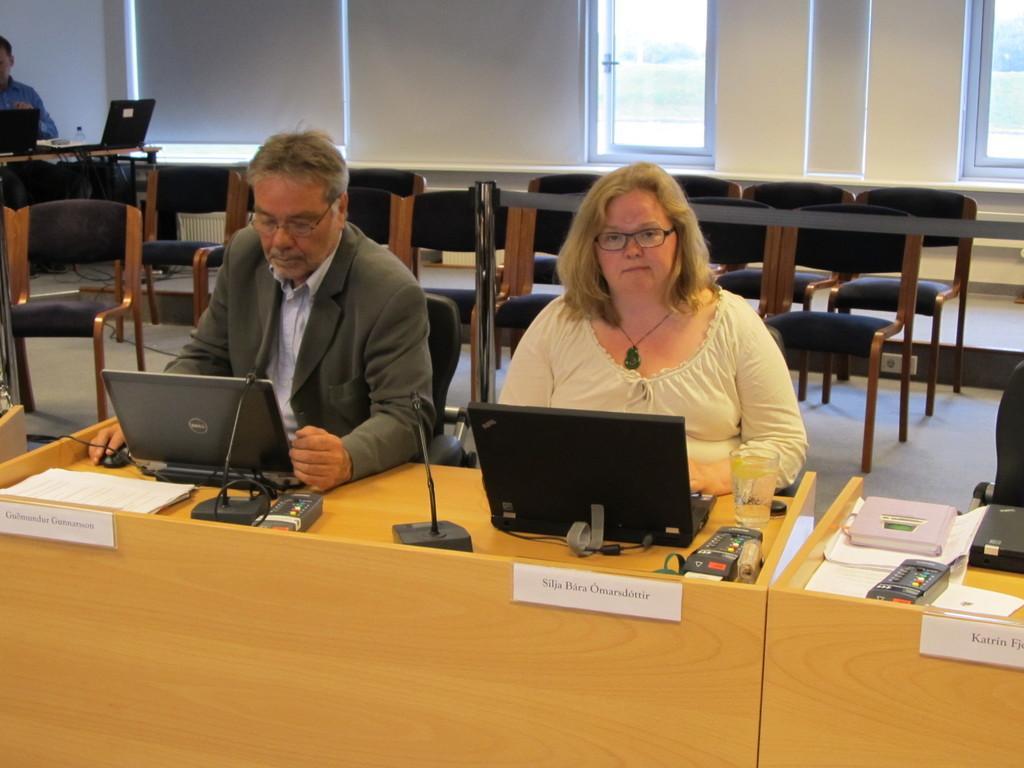In one or two sentences, can you explain what this image depicts? In this image we can see few people working on the laptops. There are many objects on the table. There are few windows in the image. There is a person at the left side of the image. There are many chairs in the image. 